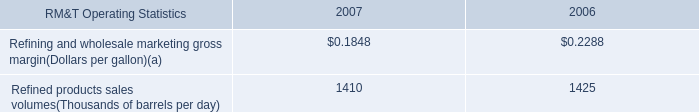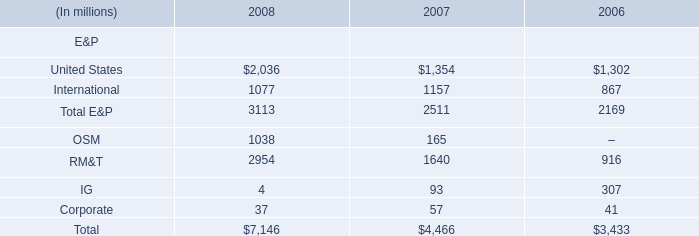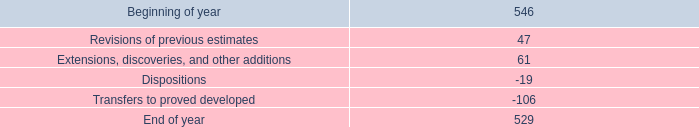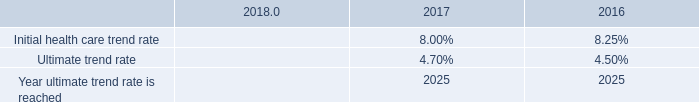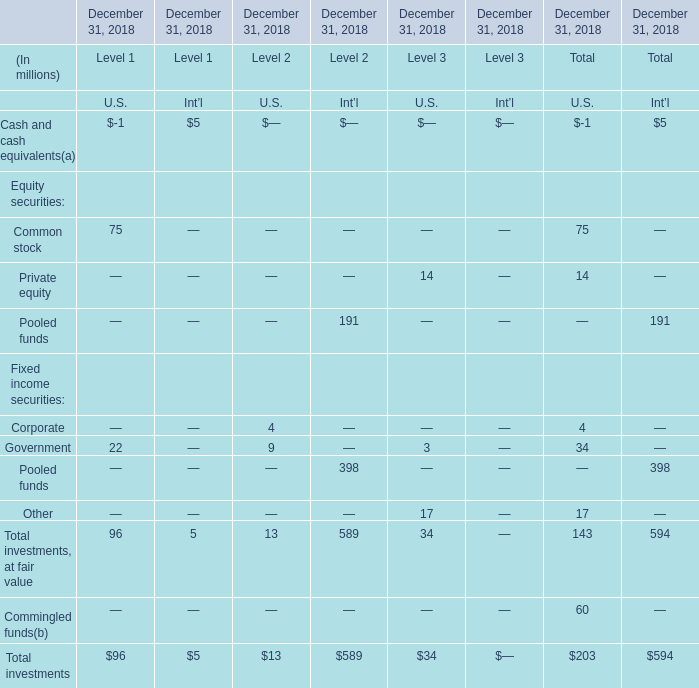What's the 50 % of the sum of the Total investments, at fair value for U.S. at December 31, 2018? (in million) 
Computations: (0.5 * 143)
Answer: 71.5. 